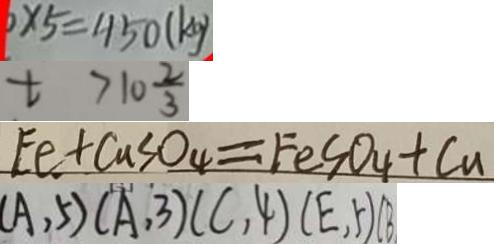Convert formula to latex. <formula><loc_0><loc_0><loc_500><loc_500>\times 5 = 4 5 0 ( k g ) 
 t > 1 0 \frac { 2 } { 3 } 
 F e + C u S O _ { 4 } = F e S O _ { 4 } + C u 
 ( A , 5 ) ( A , 3 ) ( C , 4 ) ( E , 5 ) ( B</formula> 